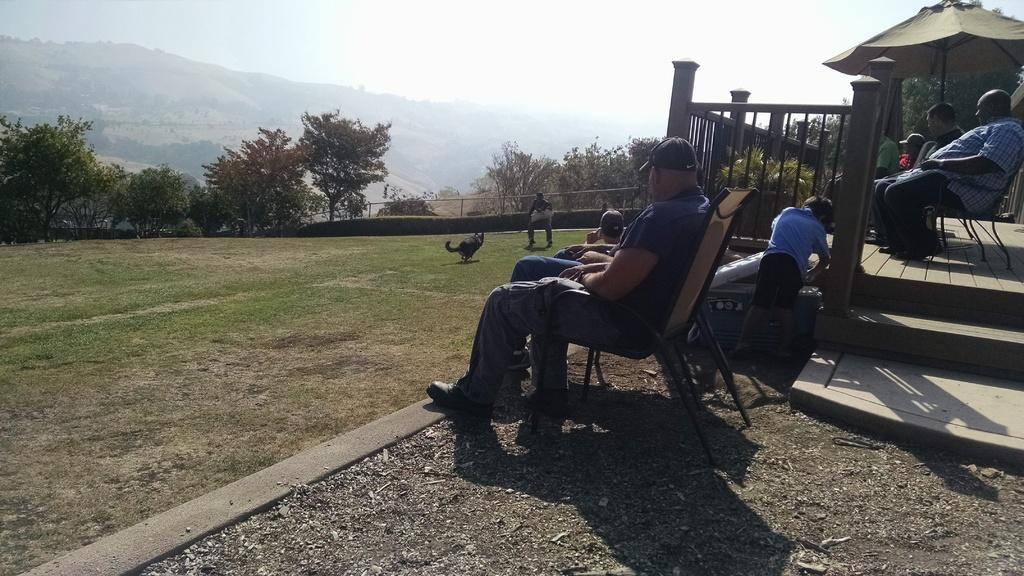How would you summarize this image in a sentence or two? In this image I can see a person wearing black hat, blue t shirt, pant and shoe is sitting on a chair and I can see few other persons sitting on a chair under the umbrella and a person standing. In the background I can see a dog and a person on the ground, few trees, few mountains, the railing and the sky. 